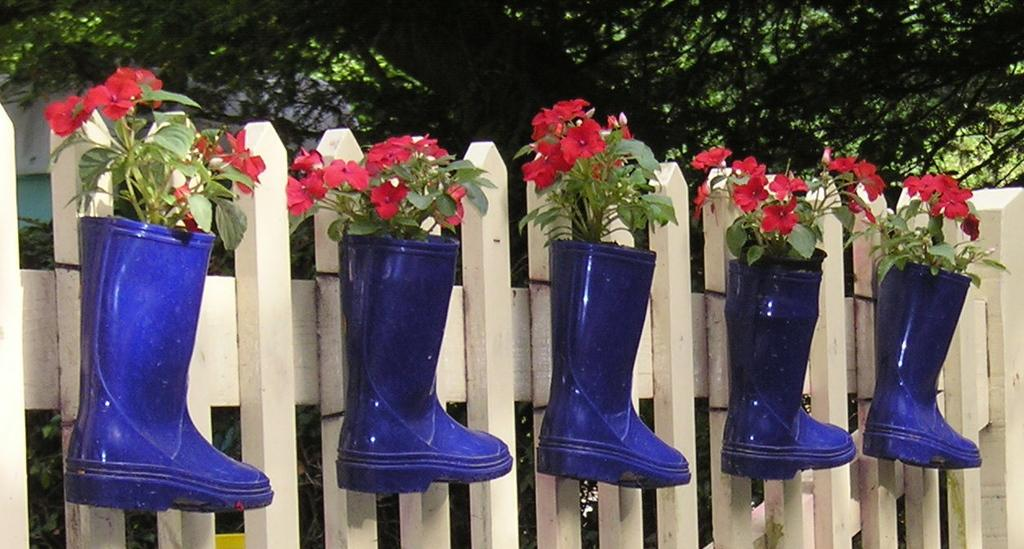What is in the foreground of the image? There are plants in blue colored boots in the foreground of the image. How are the plants positioned in the image? The plants are on fencing. What can be seen in the background of the image? There is a tree and a building in the background of the image. What type of crack can be seen in the image? There is no crack present in the image. What toys are visible in the image? There are no toys visible in the image. 